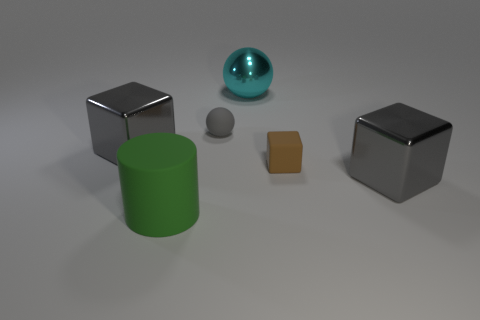There is a small gray object; is its shape the same as the big object that is behind the gray rubber sphere?
Ensure brevity in your answer.  Yes. There is a object that is behind the brown thing and on the left side of the gray rubber thing; what is its material?
Your answer should be very brief. Metal. What is the color of the cube that is the same size as the matte ball?
Offer a very short reply. Brown. Is the material of the gray ball the same as the green object that is to the left of the brown rubber block?
Keep it short and to the point. Yes. What number of other objects are there of the same size as the gray rubber sphere?
Offer a very short reply. 1. Is there a gray metal block behind the gray object that is on the right side of the large cyan metal object behind the small brown matte block?
Provide a succinct answer. Yes. The green object is what size?
Offer a terse response. Large. How big is the gray shiny block that is on the left side of the cyan metallic ball?
Ensure brevity in your answer.  Large. Does the gray object that is to the left of the rubber ball have the same size as the large cyan thing?
Keep it short and to the point. Yes. Is there any other thing of the same color as the large rubber cylinder?
Your response must be concise. No. 